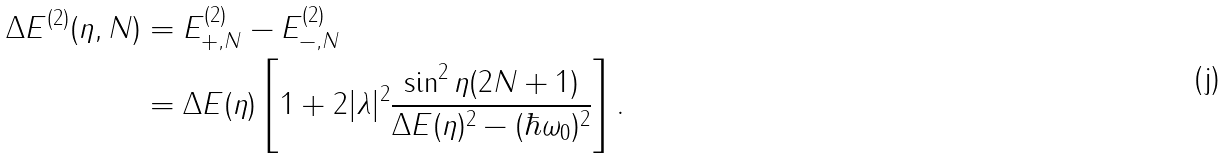Convert formula to latex. <formula><loc_0><loc_0><loc_500><loc_500>\Delta E ^ { ( 2 ) } ( \eta , N ) & = E _ { + , N } ^ { ( 2 ) } - E _ { - , N } ^ { ( 2 ) } \\ & = \Delta E ( \eta ) \left [ 1 + 2 | \lambda | ^ { 2 } \frac { \sin ^ { 2 } \eta ( 2 N + 1 ) } { \Delta E ( \eta ) ^ { 2 } - ( \hbar { \omega } _ { 0 } ) ^ { 2 } } \right ] .</formula> 